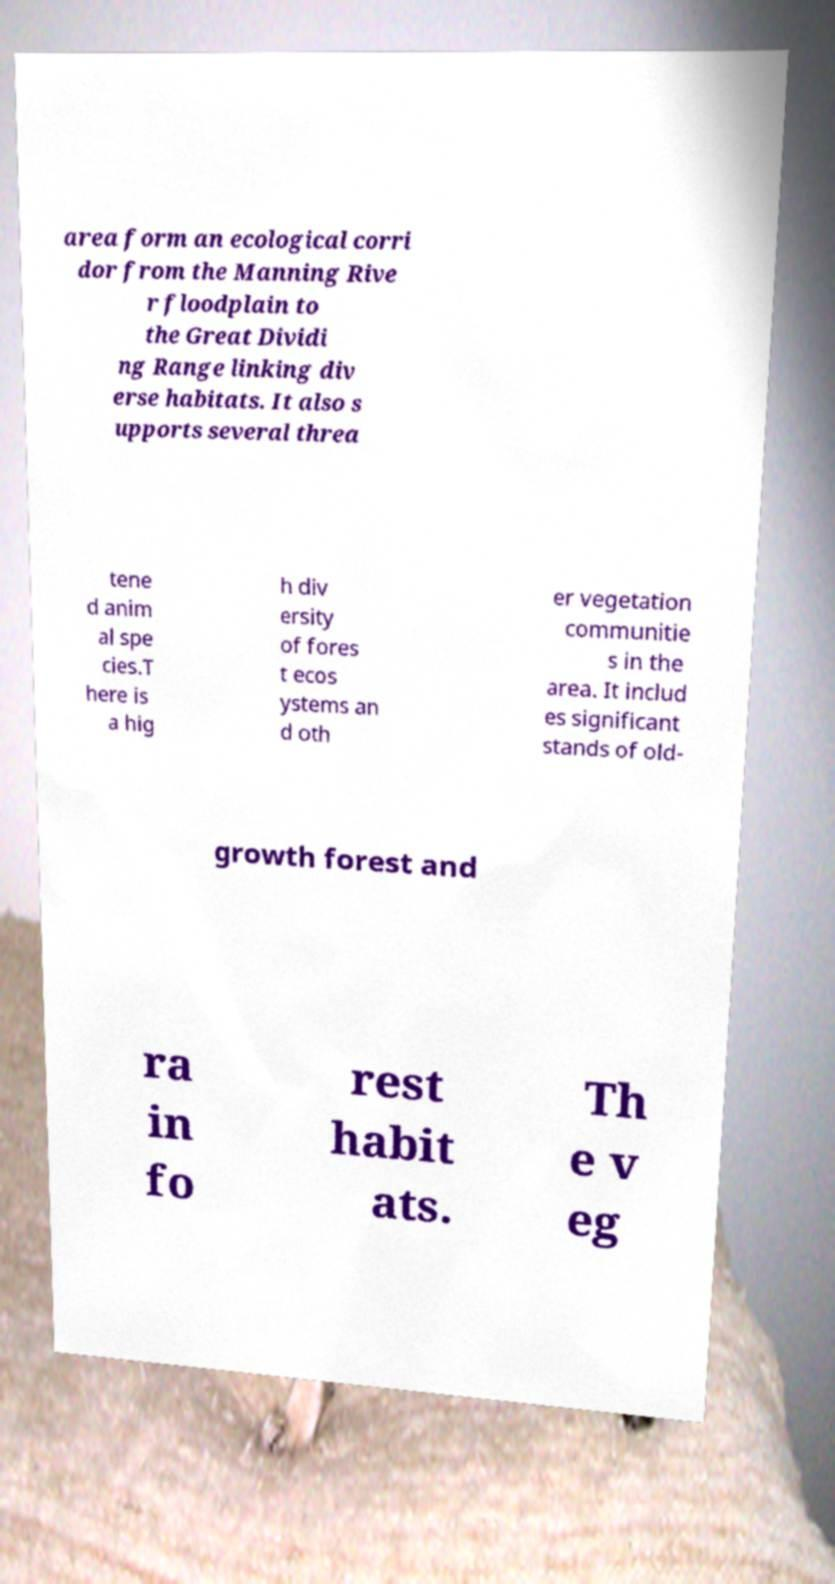For documentation purposes, I need the text within this image transcribed. Could you provide that? area form an ecological corri dor from the Manning Rive r floodplain to the Great Dividi ng Range linking div erse habitats. It also s upports several threa tene d anim al spe cies.T here is a hig h div ersity of fores t ecos ystems an d oth er vegetation communitie s in the area. It includ es significant stands of old- growth forest and ra in fo rest habit ats. Th e v eg 